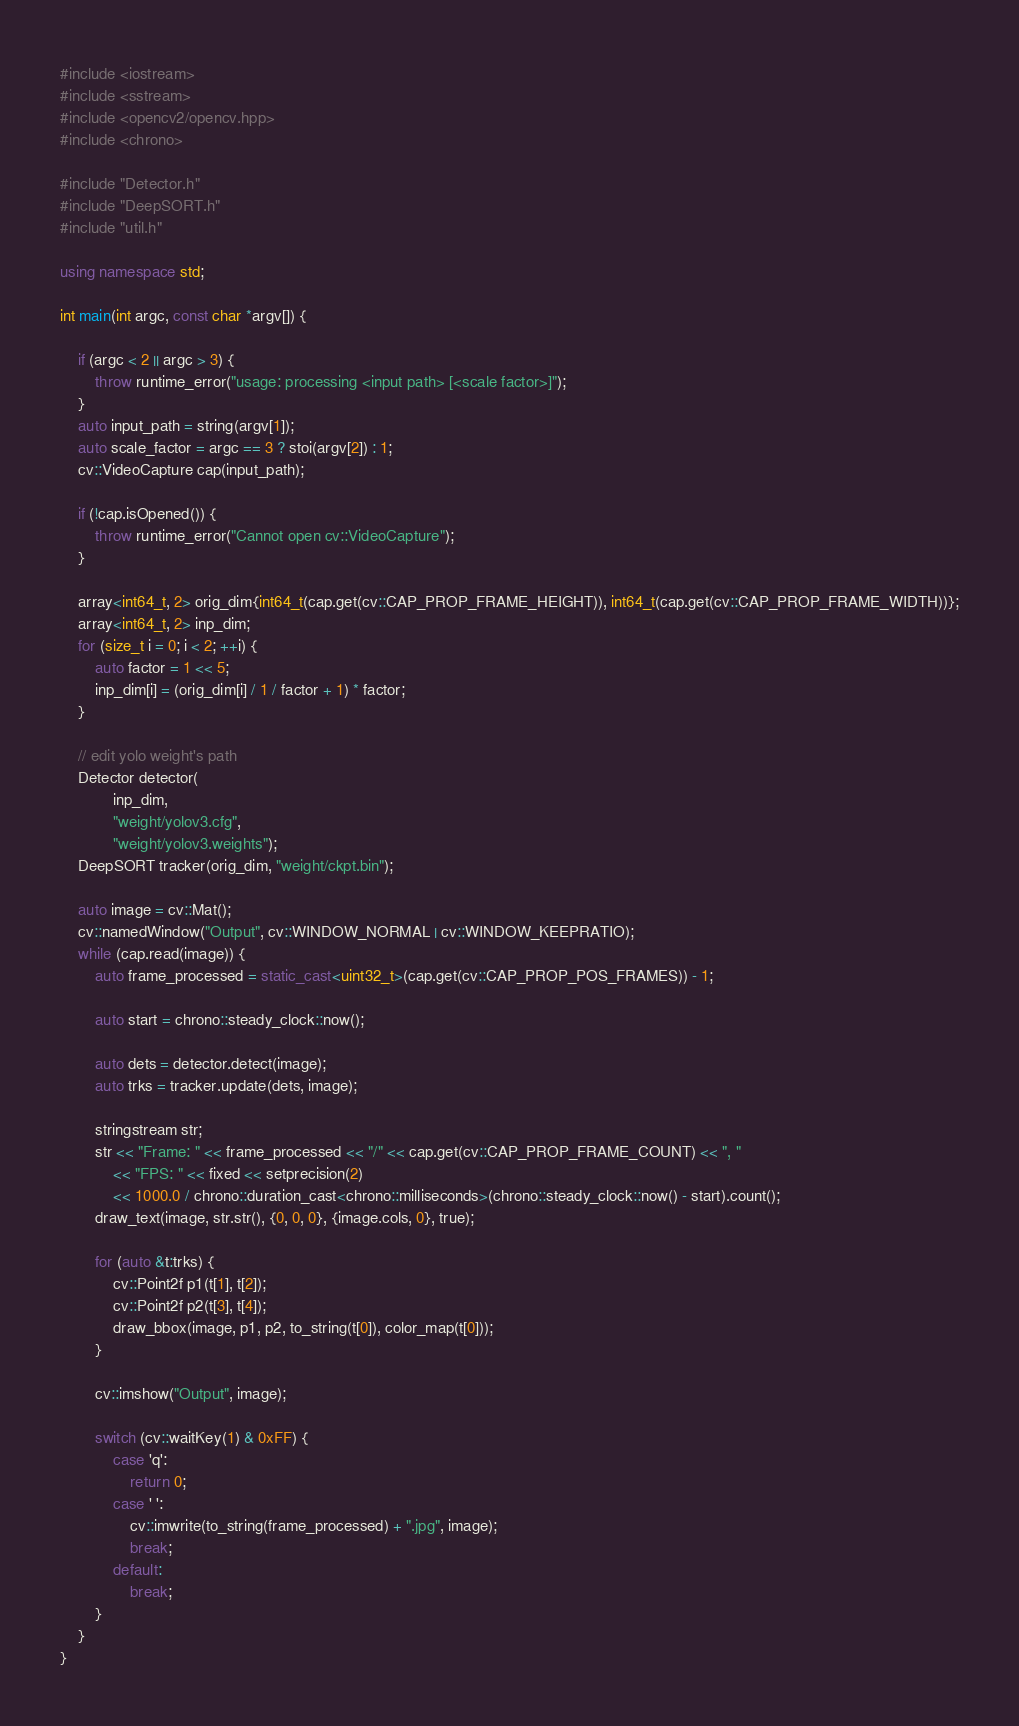<code> <loc_0><loc_0><loc_500><loc_500><_C++_>#include <iostream>
#include <sstream>
#include <opencv2/opencv.hpp>
#include <chrono>

#include "Detector.h"
#include "DeepSORT.h"
#include "util.h"

using namespace std;

int main(int argc, const char *argv[]) {

    if (argc < 2 || argc > 3) {
        throw runtime_error("usage: processing <input path> [<scale factor>]");
    }
    auto input_path = string(argv[1]);
    auto scale_factor = argc == 3 ? stoi(argv[2]) : 1;
    cv::VideoCapture cap(input_path);

    if (!cap.isOpened()) {
        throw runtime_error("Cannot open cv::VideoCapture");
    }

    array<int64_t, 2> orig_dim{int64_t(cap.get(cv::CAP_PROP_FRAME_HEIGHT)), int64_t(cap.get(cv::CAP_PROP_FRAME_WIDTH))};
    array<int64_t, 2> inp_dim;
    for (size_t i = 0; i < 2; ++i) {
        auto factor = 1 << 5;
        inp_dim[i] = (orig_dim[i] / 1 / factor + 1) * factor;
    }

    // edit yolo weight's path
    Detector detector(
            inp_dim,
            "weight/yolov3.cfg",
            "weight/yolov3.weights");
    DeepSORT tracker(orig_dim, "weight/ckpt.bin");

    auto image = cv::Mat();
    cv::namedWindow("Output", cv::WINDOW_NORMAL | cv::WINDOW_KEEPRATIO);
    while (cap.read(image)) {
        auto frame_processed = static_cast<uint32_t>(cap.get(cv::CAP_PROP_POS_FRAMES)) - 1;

        auto start = chrono::steady_clock::now();

        auto dets = detector.detect(image);
        auto trks = tracker.update(dets, image);

        stringstream str;
        str << "Frame: " << frame_processed << "/" << cap.get(cv::CAP_PROP_FRAME_COUNT) << ", "
            << "FPS: " << fixed << setprecision(2)
            << 1000.0 / chrono::duration_cast<chrono::milliseconds>(chrono::steady_clock::now() - start).count();
        draw_text(image, str.str(), {0, 0, 0}, {image.cols, 0}, true);

        for (auto &t:trks) {
            cv::Point2f p1(t[1], t[2]);
            cv::Point2f p2(t[3], t[4]);
            draw_bbox(image, p1, p2, to_string(t[0]), color_map(t[0]));
        }

        cv::imshow("Output", image);

        switch (cv::waitKey(1) & 0xFF) {
            case 'q':
                return 0;
            case ' ':
                cv::imwrite(to_string(frame_processed) + ".jpg", image);
                break;
            default:
                break;
        }
    }
}</code> 